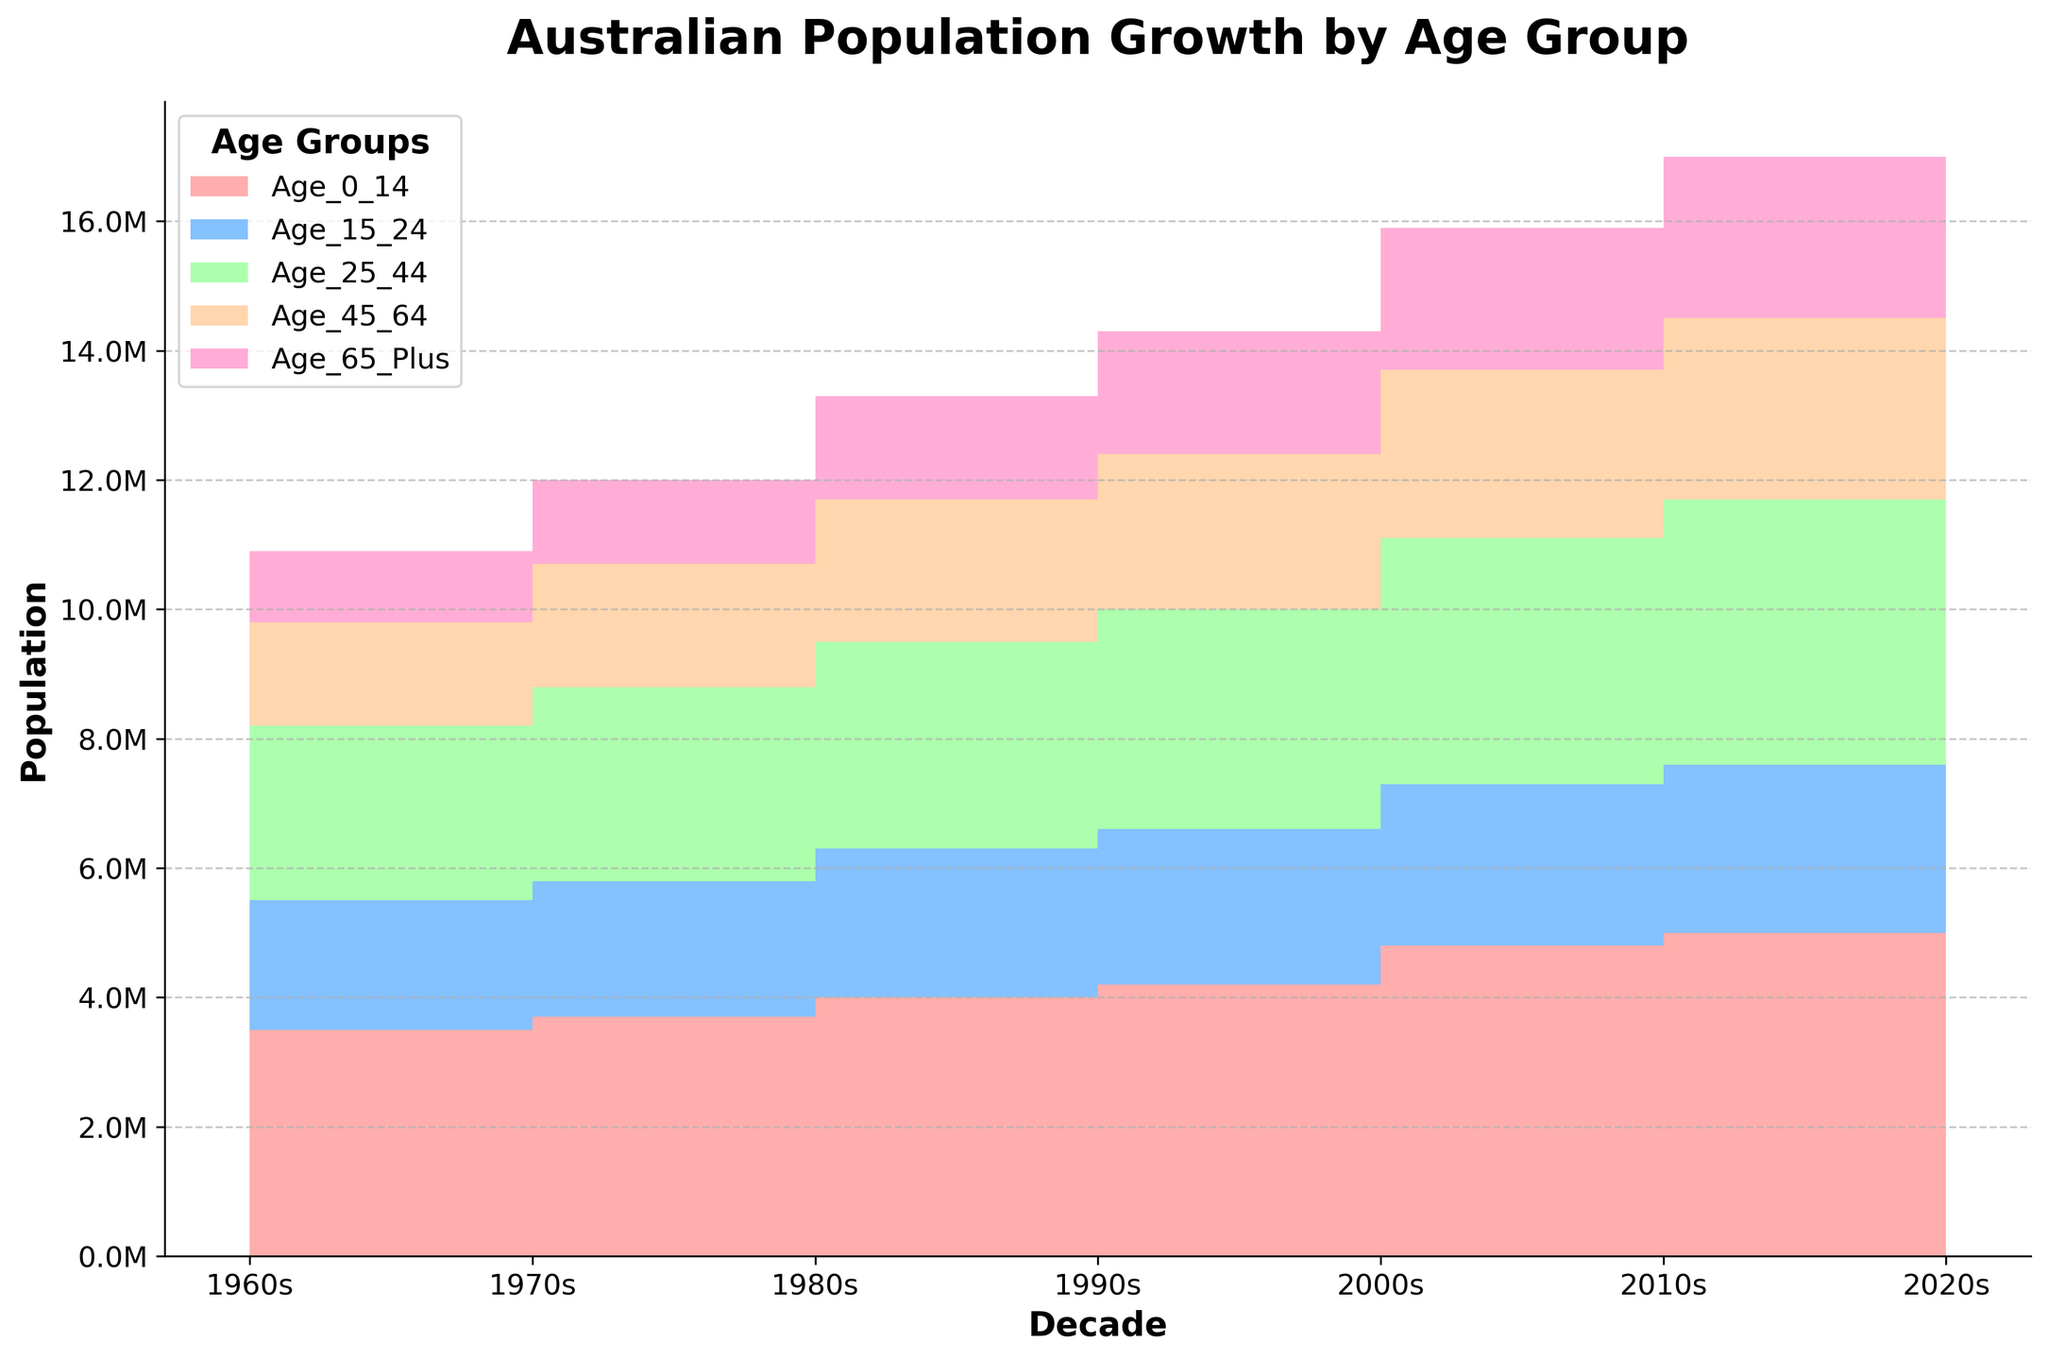What is the title of the chart? The title of the chart is displayed in a large, bold font at the top. It reads, "Australian Population Growth by Age Group".
Answer: Australian Population Growth by Age Group How does the population of the 'Age 0-14' group in the 1960s compare to the population in the 2000s? The 'Age 0-14' population in the 1960s is around 3.1 million, and it increases to roughly 4.2 million in the 2000s. By calculating the difference, we find that the population grew by approximately 1.1 million.
Answer: Increased by 1.1 million Which decade shows the highest population for the 'Age 65 Plus' group? By examining the thickness of the topmost color band in the step area chart, the 2020s have the thickest band for the 'Age 65 Plus' group.
Answer: 2020s Summing up the populations of the 'Age 25-44' and 'Age 45-64' groups, which decade shows the highest combined population? Adding the populations together by decade, you see that the 2020s have the highest combined population: 'Age 25-44' (4.1 million) + 'Age 45-64' (2.8 million) = 6.9 million.
Answer: 2020s What is the primary color used to represent the 'Age 15-24' group in the chart? The 'Age 15-24' group is represented by a shade of blue in the step area chart.
Answer: Blue Between the 1990s and 2000s, which age group shows the most significant increase in population? By comparing the step areas for each age group between the 1990s and 2000s, the 'Age 65 Plus' group shows the most significant increase.
Answer: Age 65 Plus Which age group has a consistently rising population across all decades? Observing the trend over the decades, the 'Age 65 Plus' group shows a consistent increase in population.
Answer: Age 65 Plus In the decade of the 1980s, which age group had the lowest population? By examining the chart, the 'Age 65 Plus' group has the smallest area in the 1980s, indicating the lowest population among the age groups.
Answer: Age 65 Plus 